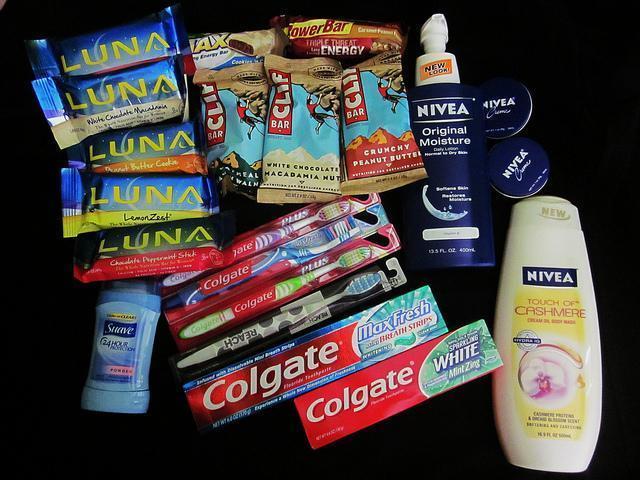How many toothbrushes are there?
Give a very brief answer. 3. How many bottles are there?
Give a very brief answer. 2. How many dogs are sitting on the furniture?
Give a very brief answer. 0. 